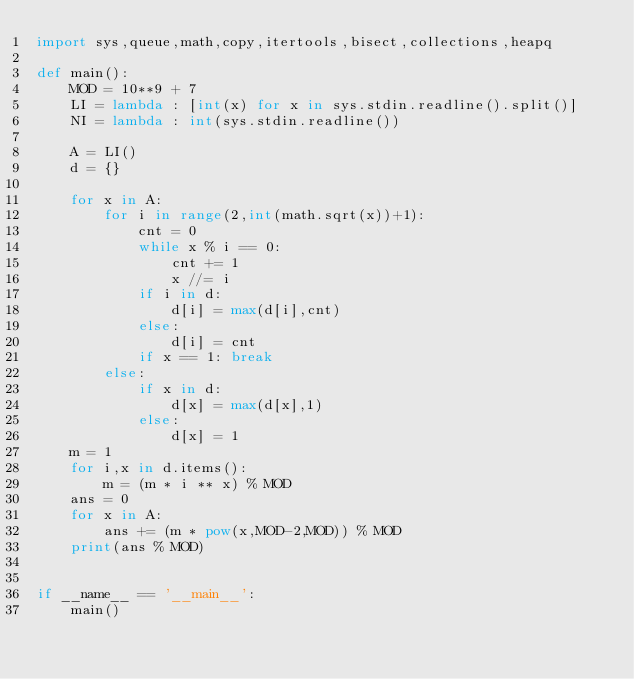<code> <loc_0><loc_0><loc_500><loc_500><_Python_>import sys,queue,math,copy,itertools,bisect,collections,heapq

def main():
    MOD = 10**9 + 7
    LI = lambda : [int(x) for x in sys.stdin.readline().split()]
    NI = lambda : int(sys.stdin.readline())

    A = LI()
    d = {}

    for x in A:
        for i in range(2,int(math.sqrt(x))+1):
            cnt = 0
            while x % i == 0:
                cnt += 1
                x //= i
            if i in d:
                d[i] = max(d[i],cnt)
            else:
                d[i] = cnt
            if x == 1: break
        else:
            if x in d:
                d[x] = max(d[x],1)
            else:
                d[x] = 1
    m = 1
    for i,x in d.items():
        m = (m * i ** x) % MOD
    ans = 0
    for x in A:
        ans += (m * pow(x,MOD-2,MOD)) % MOD
    print(ans % MOD)


if __name__ == '__main__':
    main()</code> 